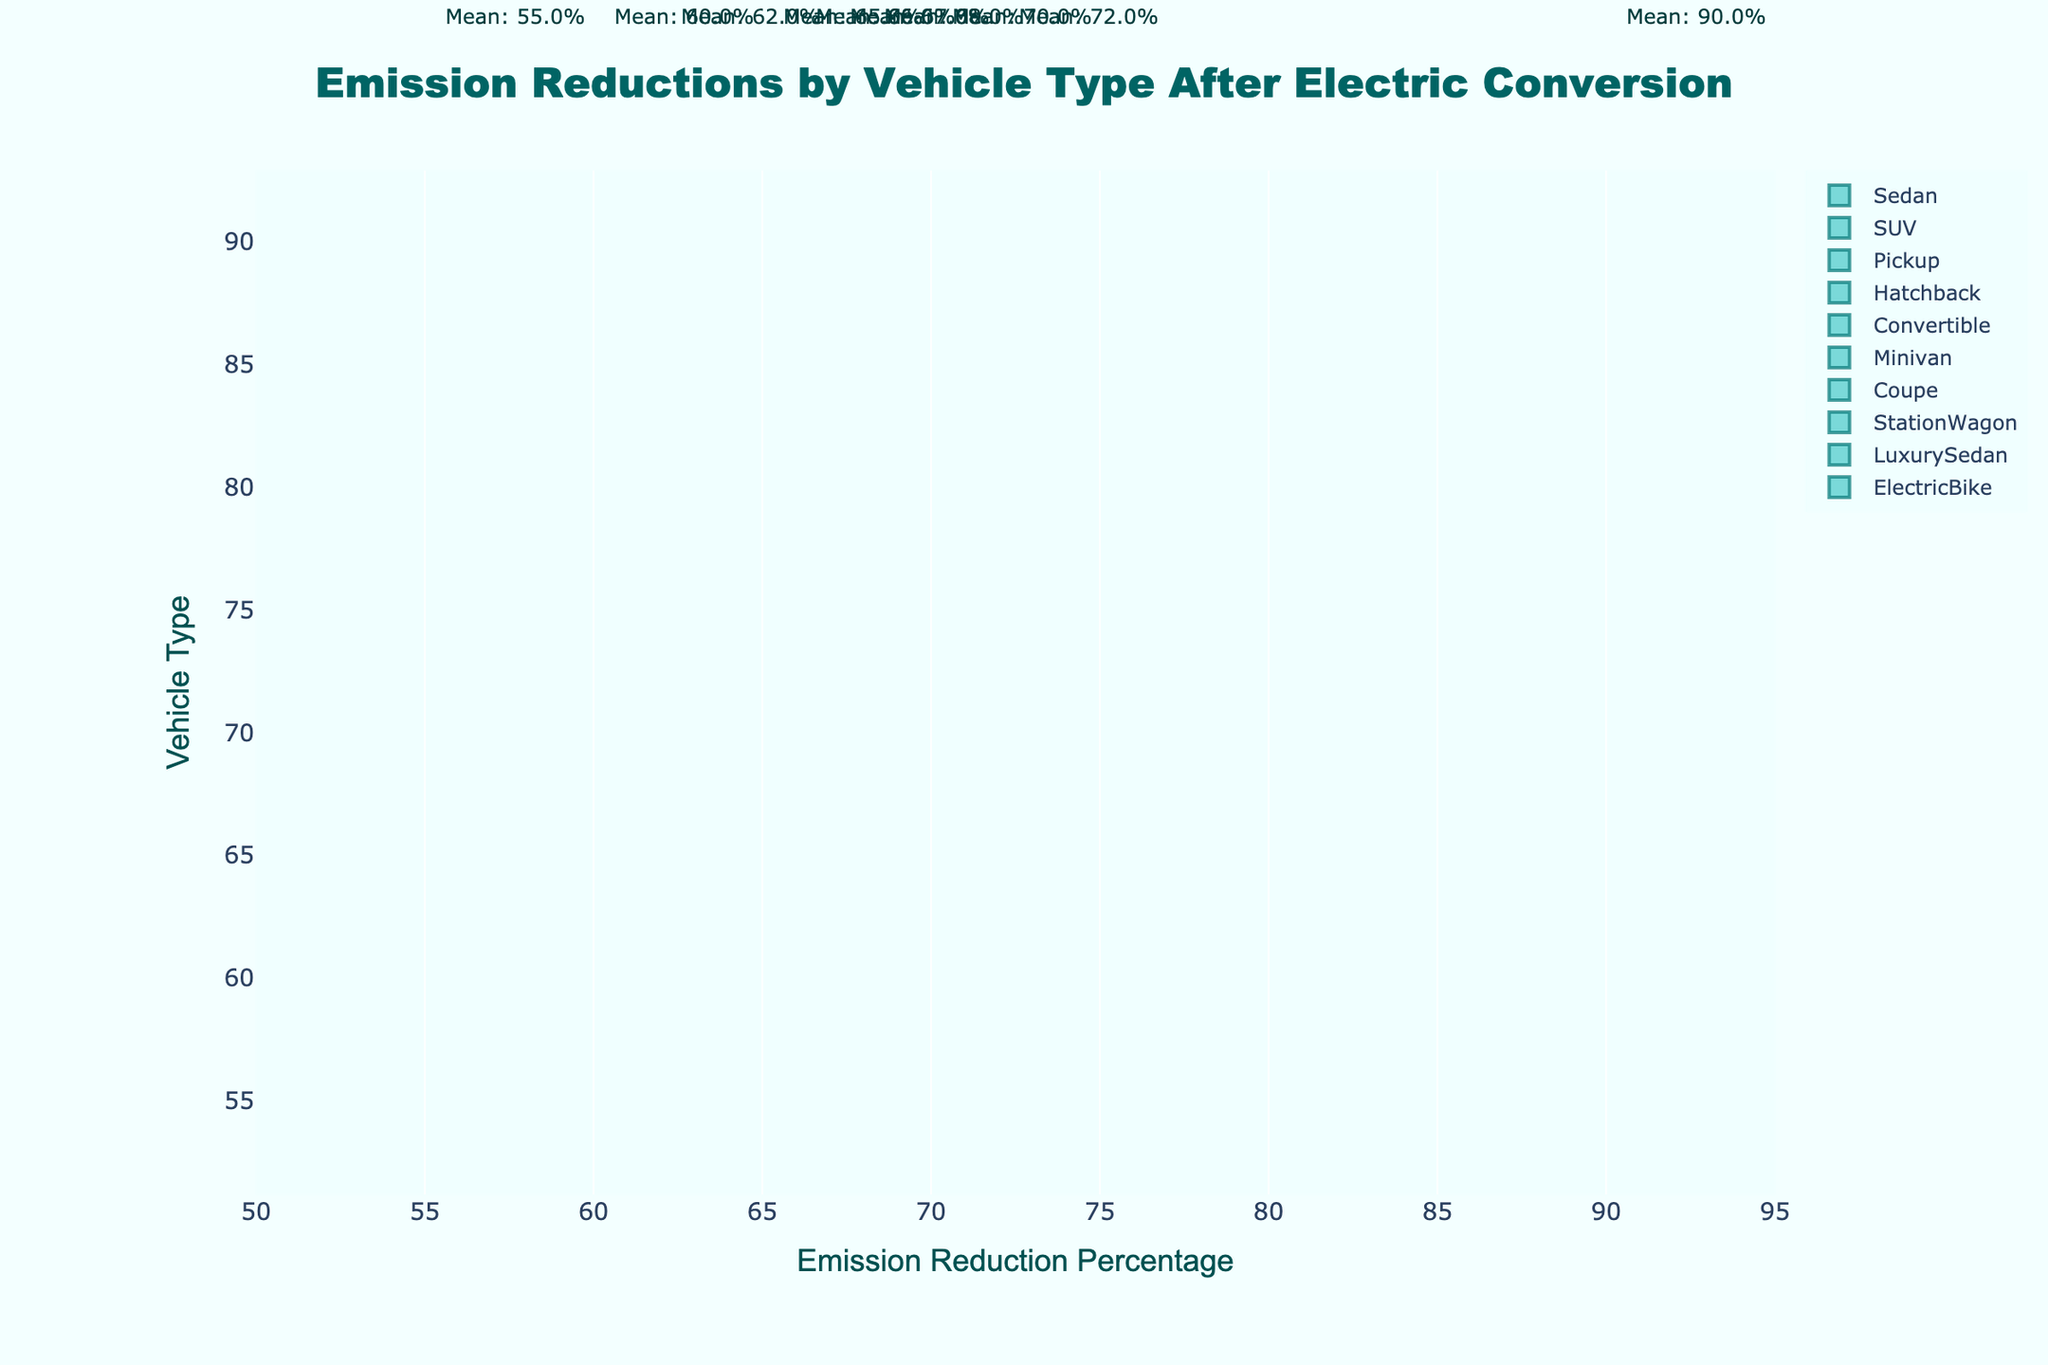What is the highest emission reduction percentage shown on the chart? The highest emission reduction percentage is represented by the Electric Bike, which shows around 90%. This can be confirmed by looking at the farthest data points on the right side of the chart.
Answer: 90% Which vehicle type shows the lowest emission reduction percentage? By examining the plot, the Pickup truck shows the lowest emission reduction percentage at around 55%. This is evident by the leftmost points on the section labeled "Pickup".
Answer: Pickup What is the mean emission reduction percentage for SUVs? According to the figure, the mean emission reduction percentage for SUVs is displayed on the chart, which is around 60%. The mean values are annotated next to each vehicle type on the plot.
Answer: 60% How much higher is the mean emission reduction percentage for Luxury Sedans compared to Convertibles? The mean emission reduction percentage for Luxury Sedans is approximately 72%, while for Convertibles it is around 65%. Subtracting these values gives 72 - 65 = 7%.
Answer: 7% Which vehicle type has mean emission reduction percentages close to 66-67%? Both Station Wagon and Coupe have mean emission reduction percentages close to 66% and 67%, respectively, as annotated on the plot.
Answer: Station Wagon and Coupe Which vehicle types have an emission reduction percentage higher than 70%? The Electric Bike and Luxury Sedan show emission reduction percentages higher than 70%, as evident from their positions on the horizontal axis. Electric Bike reaches up to 90% and Luxury Sedan is around 72%.
Answer: Electric Bike and Luxury Sedan What can be said about the spread of emission reduction percentages for Minivans compared to Sedans? Minivans show a slightly narrower spread compared to Sedans because the points for Minivans are clustered more closely together around their mean value, while the span for Sedans is wider around their mean.
Answer: Minivans have a narrower spread Which vehicle type has the closest mean emission reduction percentage to Hatchbacks? Both Hatchbacks and Coupes have similar mean emission reduction percentages, with Hatchbacks at around 68% and Coupes at around 67%, indicated by the annotations near their respective plots.
Answer: Coupe 